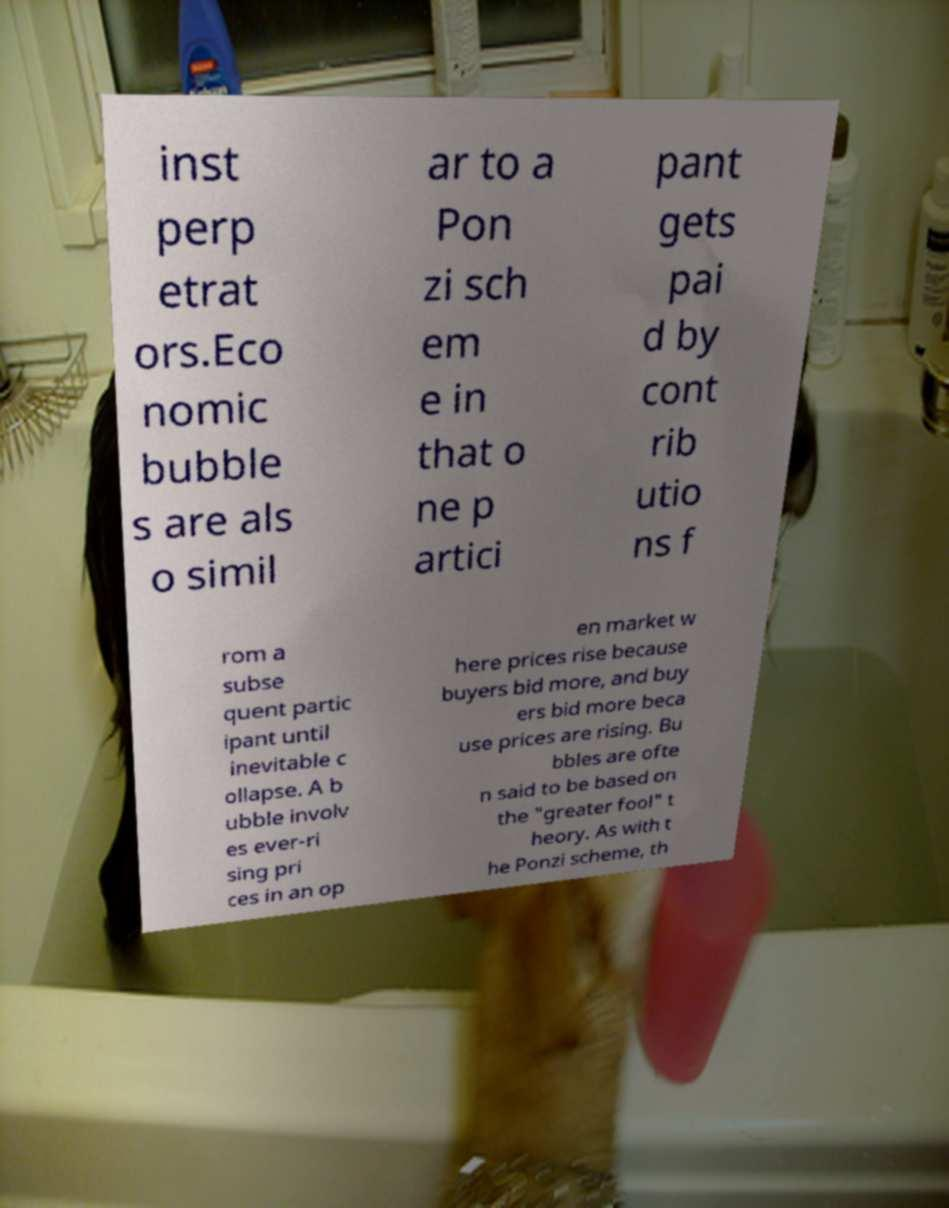For documentation purposes, I need the text within this image transcribed. Could you provide that? inst perp etrat ors.Eco nomic bubble s are als o simil ar to a Pon zi sch em e in that o ne p artici pant gets pai d by cont rib utio ns f rom a subse quent partic ipant until inevitable c ollapse. A b ubble involv es ever-ri sing pri ces in an op en market w here prices rise because buyers bid more, and buy ers bid more beca use prices are rising. Bu bbles are ofte n said to be based on the "greater fool" t heory. As with t he Ponzi scheme, th 